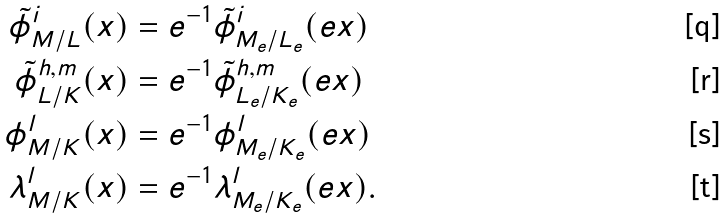Convert formula to latex. <formula><loc_0><loc_0><loc_500><loc_500>\tilde { \phi } _ { M / L } ^ { i } ( x ) & = e ^ { - 1 } \tilde { \phi } _ { M _ { e } / L _ { e } } ^ { i } ( e x ) \\ \tilde { \phi } _ { L / K } ^ { h , m } ( x ) & = e ^ { - 1 } \tilde { \phi } _ { L _ { e } / K _ { e } } ^ { h , m } ( e x ) \\ \phi _ { M / K } ^ { l } ( x ) & = e ^ { - 1 } \phi _ { M _ { e } / K _ { e } } ^ { l } ( e x ) \\ \lambda _ { M / K } ^ { l } ( x ) & = e ^ { - 1 } \lambda _ { M _ { e } / K _ { e } } ^ { l } ( e x ) .</formula> 